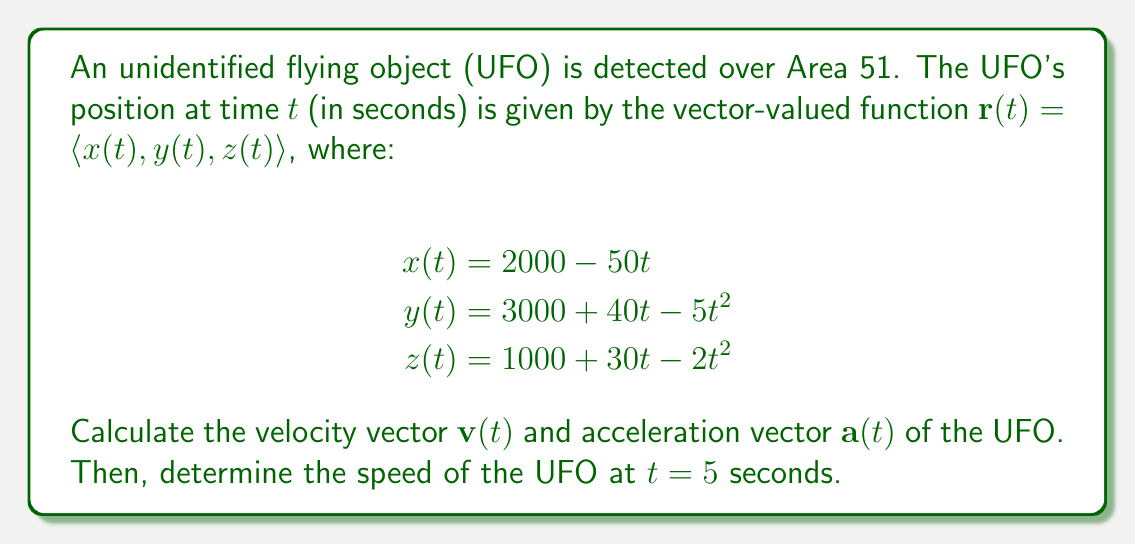Show me your answer to this math problem. To solve this problem, we need to use differential equations and vector calculus. Let's break it down step by step:

1. Velocity vector $\mathbf{v}(t)$:
   The velocity vector is the first derivative of the position vector with respect to time.
   
   $$\mathbf{v}(t) = \frac{d}{dt}\mathbf{r}(t) = \left\langle \frac{dx}{dt}, \frac{dy}{dt}, \frac{dz}{dt} \right\rangle$$
   
   $$\frac{dx}{dt} = -50$$
   $$\frac{dy}{dt} = 40 - 10t$$
   $$\frac{dz}{dt} = 30 - 4t$$
   
   Therefore, $\mathbf{v}(t) = \langle -50, 40-10t, 30-4t \rangle$

2. Acceleration vector $\mathbf{a}(t)$:
   The acceleration vector is the second derivative of the position vector, or the first derivative of the velocity vector.
   
   $$\mathbf{a}(t) = \frac{d}{dt}\mathbf{v}(t) = \left\langle \frac{d^2x}{dt^2}, \frac{d^2y}{dt^2}, \frac{d^2z}{dt^2} \right\rangle$$
   
   $$\frac{d^2x}{dt^2} = 0$$
   $$\frac{d^2y}{dt^2} = -10$$
   $$\frac{d^2z}{dt^2} = -4$$
   
   Therefore, $\mathbf{a}(t) = \langle 0, -10, -4 \rangle$

3. Speed at $t = 5$ seconds:
   The speed is the magnitude of the velocity vector. We can calculate this using the Pythagorean theorem in three dimensions.
   
   $$\text{Speed} = \|\mathbf{v}(t)\| = \sqrt{v_x^2 + v_y^2 + v_z^2}$$
   
   At $t = 5$:
   $$\mathbf{v}(5) = \langle -50, 40-10(5), 30-4(5) \rangle = \langle -50, -10, 10 \rangle$$
   
   $$\text{Speed} = \sqrt{(-50)^2 + (-10)^2 + (10)^2} = \sqrt{2500 + 100 + 100} = \sqrt{2700} \approx 51.96$$
Answer: Velocity vector: $\mathbf{v}(t) = \langle -50, 40-10t, 30-4t \rangle$
Acceleration vector: $\mathbf{a}(t) = \langle 0, -10, -4 \rangle$
Speed at $t = 5$ seconds: $\sqrt{2700} \approx 51.96$ units/second 